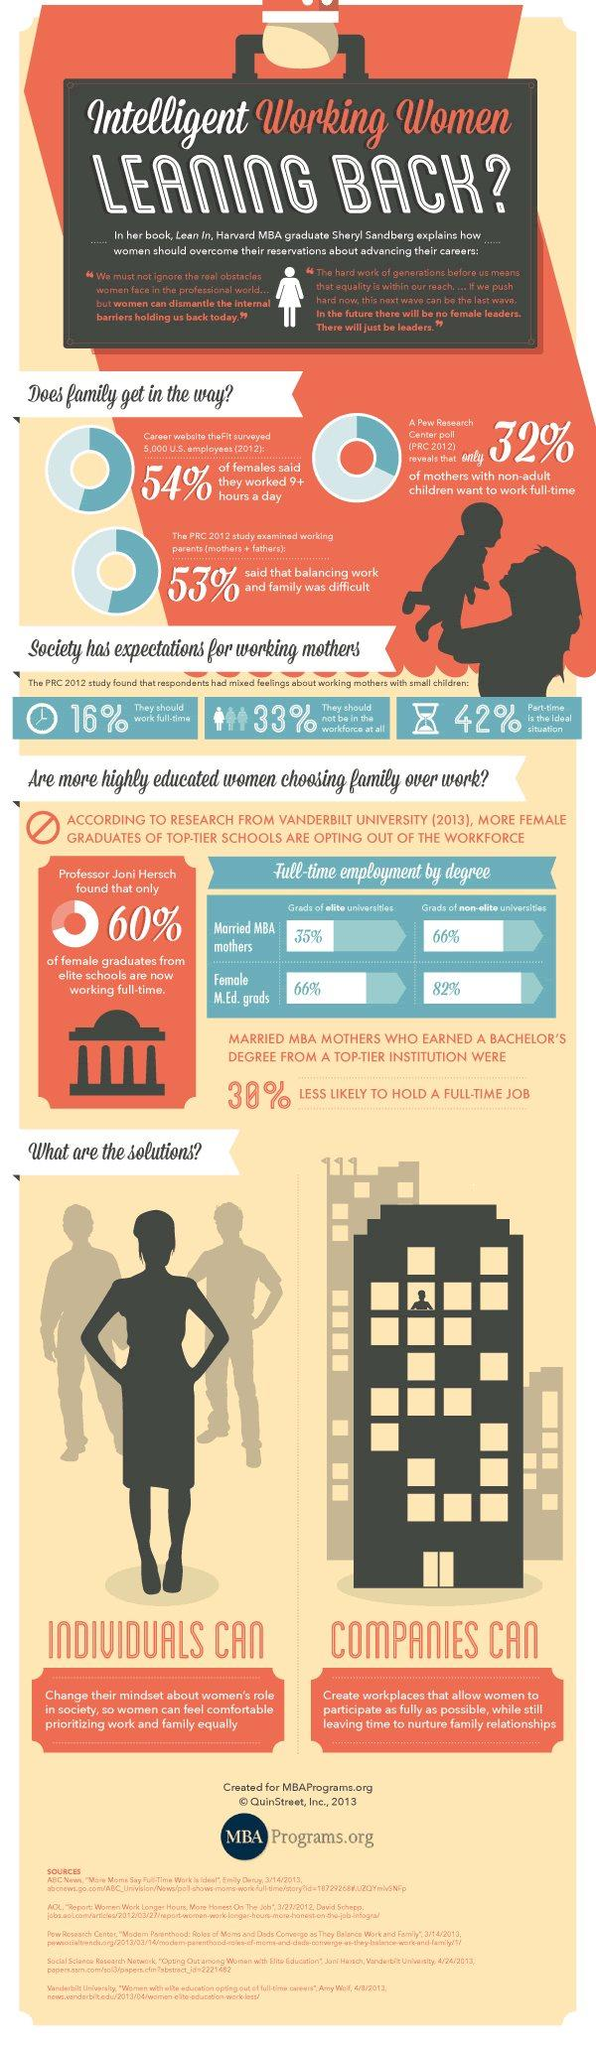Outline some significant characteristics in this image. According to a recent survey, 68% of mothers with non-adult children do not want to work full-time. Approximately 40% of female graduates from elite schools are not currently working full-time. 